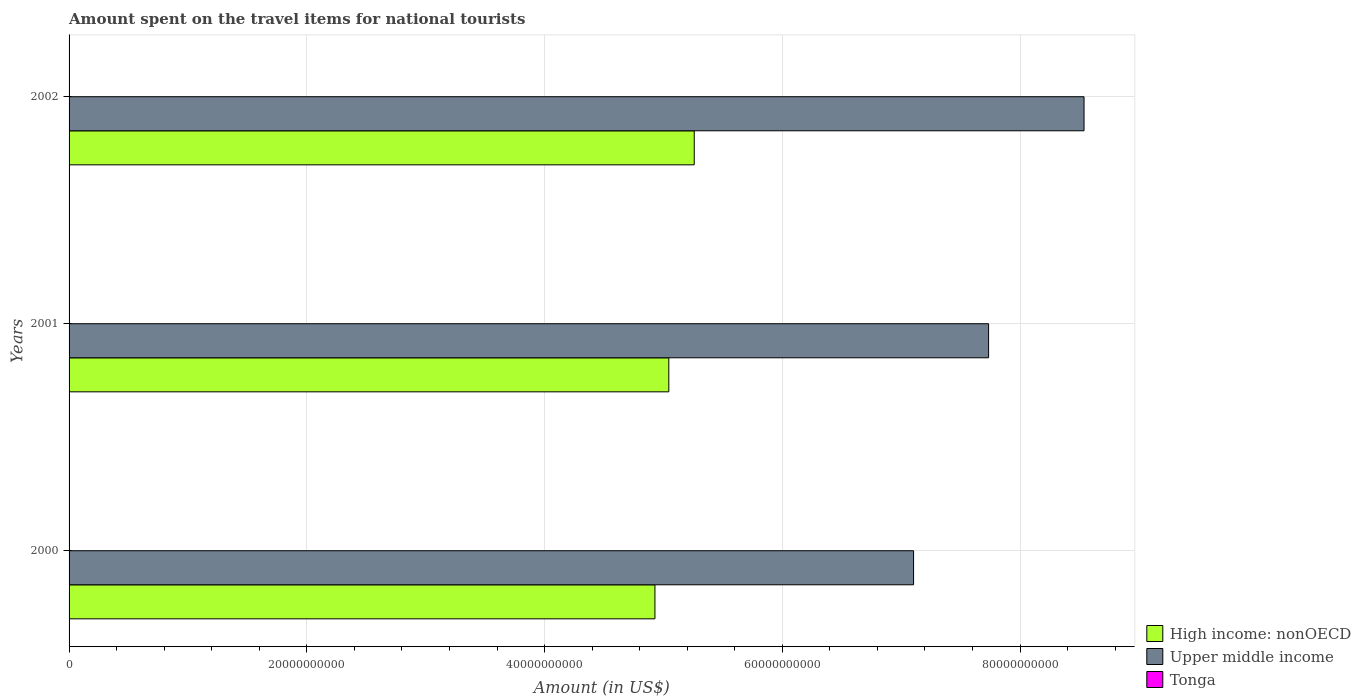How many groups of bars are there?
Make the answer very short. 3. Are the number of bars per tick equal to the number of legend labels?
Your answer should be very brief. Yes. Are the number of bars on each tick of the Y-axis equal?
Keep it short and to the point. Yes. How many bars are there on the 2nd tick from the bottom?
Offer a terse response. 3. In how many cases, is the number of bars for a given year not equal to the number of legend labels?
Provide a short and direct response. 0. What is the amount spent on the travel items for national tourists in High income: nonOECD in 2002?
Give a very brief answer. 5.26e+1. Across all years, what is the maximum amount spent on the travel items for national tourists in High income: nonOECD?
Make the answer very short. 5.26e+1. Across all years, what is the minimum amount spent on the travel items for national tourists in Upper middle income?
Make the answer very short. 7.10e+1. What is the total amount spent on the travel items for national tourists in High income: nonOECD in the graph?
Your answer should be compact. 1.52e+11. What is the difference between the amount spent on the travel items for national tourists in High income: nonOECD in 2000 and that in 2002?
Ensure brevity in your answer.  -3.31e+09. What is the difference between the amount spent on the travel items for national tourists in Upper middle income in 2001 and the amount spent on the travel items for national tourists in High income: nonOECD in 2002?
Provide a succinct answer. 2.48e+1. What is the average amount spent on the travel items for national tourists in Upper middle income per year?
Your response must be concise. 7.79e+1. In the year 2001, what is the difference between the amount spent on the travel items for national tourists in Upper middle income and amount spent on the travel items for national tourists in Tonga?
Ensure brevity in your answer.  7.73e+1. What is the ratio of the amount spent on the travel items for national tourists in High income: nonOECD in 2000 to that in 2001?
Provide a succinct answer. 0.98. Is the difference between the amount spent on the travel items for national tourists in Upper middle income in 2000 and 2001 greater than the difference between the amount spent on the travel items for national tourists in Tonga in 2000 and 2001?
Provide a short and direct response. No. What is the difference between the highest and the second highest amount spent on the travel items for national tourists in High income: nonOECD?
Your answer should be very brief. 2.14e+09. What is the difference between the highest and the lowest amount spent on the travel items for national tourists in Tonga?
Your answer should be compact. 1.10e+06. What does the 2nd bar from the top in 2000 represents?
Give a very brief answer. Upper middle income. What does the 1st bar from the bottom in 2002 represents?
Your answer should be very brief. High income: nonOECD. Is it the case that in every year, the sum of the amount spent on the travel items for national tourists in Tonga and amount spent on the travel items for national tourists in Upper middle income is greater than the amount spent on the travel items for national tourists in High income: nonOECD?
Offer a very short reply. Yes. How many years are there in the graph?
Give a very brief answer. 3. What is the difference between two consecutive major ticks on the X-axis?
Your answer should be compact. 2.00e+1. Are the values on the major ticks of X-axis written in scientific E-notation?
Provide a succinct answer. No. Does the graph contain any zero values?
Your response must be concise. No. Where does the legend appear in the graph?
Your answer should be very brief. Bottom right. How are the legend labels stacked?
Your response must be concise. Vertical. What is the title of the graph?
Keep it short and to the point. Amount spent on the travel items for national tourists. Does "Other small states" appear as one of the legend labels in the graph?
Offer a very short reply. No. What is the label or title of the X-axis?
Your answer should be very brief. Amount (in US$). What is the label or title of the Y-axis?
Your answer should be compact. Years. What is the Amount (in US$) of High income: nonOECD in 2000?
Ensure brevity in your answer.  4.93e+1. What is the Amount (in US$) in Upper middle income in 2000?
Your answer should be compact. 7.10e+1. What is the Amount (in US$) of High income: nonOECD in 2001?
Your response must be concise. 5.05e+1. What is the Amount (in US$) of Upper middle income in 2001?
Your answer should be compact. 7.74e+1. What is the Amount (in US$) in Tonga in 2001?
Provide a short and direct response. 6.80e+06. What is the Amount (in US$) in High income: nonOECD in 2002?
Provide a succinct answer. 5.26e+1. What is the Amount (in US$) in Upper middle income in 2002?
Make the answer very short. 8.54e+1. What is the Amount (in US$) in Tonga in 2002?
Make the answer very short. 5.90e+06. Across all years, what is the maximum Amount (in US$) in High income: nonOECD?
Offer a very short reply. 5.26e+1. Across all years, what is the maximum Amount (in US$) of Upper middle income?
Provide a succinct answer. 8.54e+1. Across all years, what is the minimum Amount (in US$) in High income: nonOECD?
Give a very brief answer. 4.93e+1. Across all years, what is the minimum Amount (in US$) of Upper middle income?
Your answer should be very brief. 7.10e+1. Across all years, what is the minimum Amount (in US$) of Tonga?
Keep it short and to the point. 5.90e+06. What is the total Amount (in US$) in High income: nonOECD in the graph?
Your answer should be very brief. 1.52e+11. What is the total Amount (in US$) of Upper middle income in the graph?
Make the answer very short. 2.34e+11. What is the total Amount (in US$) in Tonga in the graph?
Give a very brief answer. 1.97e+07. What is the difference between the Amount (in US$) of High income: nonOECD in 2000 and that in 2001?
Ensure brevity in your answer.  -1.17e+09. What is the difference between the Amount (in US$) in Upper middle income in 2000 and that in 2001?
Provide a succinct answer. -6.31e+09. What is the difference between the Amount (in US$) of Tonga in 2000 and that in 2001?
Give a very brief answer. 2.00e+05. What is the difference between the Amount (in US$) of High income: nonOECD in 2000 and that in 2002?
Provide a succinct answer. -3.31e+09. What is the difference between the Amount (in US$) of Upper middle income in 2000 and that in 2002?
Your answer should be very brief. -1.43e+1. What is the difference between the Amount (in US$) in Tonga in 2000 and that in 2002?
Offer a terse response. 1.10e+06. What is the difference between the Amount (in US$) in High income: nonOECD in 2001 and that in 2002?
Keep it short and to the point. -2.14e+09. What is the difference between the Amount (in US$) of Upper middle income in 2001 and that in 2002?
Offer a terse response. -8.03e+09. What is the difference between the Amount (in US$) of Tonga in 2001 and that in 2002?
Ensure brevity in your answer.  9.00e+05. What is the difference between the Amount (in US$) in High income: nonOECD in 2000 and the Amount (in US$) in Upper middle income in 2001?
Your answer should be compact. -2.81e+1. What is the difference between the Amount (in US$) of High income: nonOECD in 2000 and the Amount (in US$) of Tonga in 2001?
Offer a terse response. 4.93e+1. What is the difference between the Amount (in US$) of Upper middle income in 2000 and the Amount (in US$) of Tonga in 2001?
Your answer should be compact. 7.10e+1. What is the difference between the Amount (in US$) in High income: nonOECD in 2000 and the Amount (in US$) in Upper middle income in 2002?
Your response must be concise. -3.61e+1. What is the difference between the Amount (in US$) in High income: nonOECD in 2000 and the Amount (in US$) in Tonga in 2002?
Offer a very short reply. 4.93e+1. What is the difference between the Amount (in US$) of Upper middle income in 2000 and the Amount (in US$) of Tonga in 2002?
Your answer should be compact. 7.10e+1. What is the difference between the Amount (in US$) in High income: nonOECD in 2001 and the Amount (in US$) in Upper middle income in 2002?
Provide a succinct answer. -3.49e+1. What is the difference between the Amount (in US$) of High income: nonOECD in 2001 and the Amount (in US$) of Tonga in 2002?
Make the answer very short. 5.04e+1. What is the difference between the Amount (in US$) in Upper middle income in 2001 and the Amount (in US$) in Tonga in 2002?
Provide a succinct answer. 7.73e+1. What is the average Amount (in US$) of High income: nonOECD per year?
Give a very brief answer. 5.08e+1. What is the average Amount (in US$) in Upper middle income per year?
Give a very brief answer. 7.79e+1. What is the average Amount (in US$) in Tonga per year?
Keep it short and to the point. 6.57e+06. In the year 2000, what is the difference between the Amount (in US$) of High income: nonOECD and Amount (in US$) of Upper middle income?
Keep it short and to the point. -2.18e+1. In the year 2000, what is the difference between the Amount (in US$) in High income: nonOECD and Amount (in US$) in Tonga?
Provide a short and direct response. 4.93e+1. In the year 2000, what is the difference between the Amount (in US$) in Upper middle income and Amount (in US$) in Tonga?
Offer a terse response. 7.10e+1. In the year 2001, what is the difference between the Amount (in US$) of High income: nonOECD and Amount (in US$) of Upper middle income?
Your response must be concise. -2.69e+1. In the year 2001, what is the difference between the Amount (in US$) of High income: nonOECD and Amount (in US$) of Tonga?
Your response must be concise. 5.04e+1. In the year 2001, what is the difference between the Amount (in US$) of Upper middle income and Amount (in US$) of Tonga?
Offer a very short reply. 7.73e+1. In the year 2002, what is the difference between the Amount (in US$) in High income: nonOECD and Amount (in US$) in Upper middle income?
Keep it short and to the point. -3.28e+1. In the year 2002, what is the difference between the Amount (in US$) in High income: nonOECD and Amount (in US$) in Tonga?
Your response must be concise. 5.26e+1. In the year 2002, what is the difference between the Amount (in US$) of Upper middle income and Amount (in US$) of Tonga?
Give a very brief answer. 8.54e+1. What is the ratio of the Amount (in US$) of High income: nonOECD in 2000 to that in 2001?
Offer a terse response. 0.98. What is the ratio of the Amount (in US$) in Upper middle income in 2000 to that in 2001?
Provide a short and direct response. 0.92. What is the ratio of the Amount (in US$) of Tonga in 2000 to that in 2001?
Offer a terse response. 1.03. What is the ratio of the Amount (in US$) of High income: nonOECD in 2000 to that in 2002?
Provide a succinct answer. 0.94. What is the ratio of the Amount (in US$) in Upper middle income in 2000 to that in 2002?
Give a very brief answer. 0.83. What is the ratio of the Amount (in US$) in Tonga in 2000 to that in 2002?
Make the answer very short. 1.19. What is the ratio of the Amount (in US$) in High income: nonOECD in 2001 to that in 2002?
Give a very brief answer. 0.96. What is the ratio of the Amount (in US$) of Upper middle income in 2001 to that in 2002?
Provide a short and direct response. 0.91. What is the ratio of the Amount (in US$) in Tonga in 2001 to that in 2002?
Ensure brevity in your answer.  1.15. What is the difference between the highest and the second highest Amount (in US$) in High income: nonOECD?
Your answer should be compact. 2.14e+09. What is the difference between the highest and the second highest Amount (in US$) of Upper middle income?
Ensure brevity in your answer.  8.03e+09. What is the difference between the highest and the second highest Amount (in US$) in Tonga?
Offer a terse response. 2.00e+05. What is the difference between the highest and the lowest Amount (in US$) of High income: nonOECD?
Your answer should be compact. 3.31e+09. What is the difference between the highest and the lowest Amount (in US$) in Upper middle income?
Provide a succinct answer. 1.43e+1. What is the difference between the highest and the lowest Amount (in US$) in Tonga?
Your answer should be compact. 1.10e+06. 